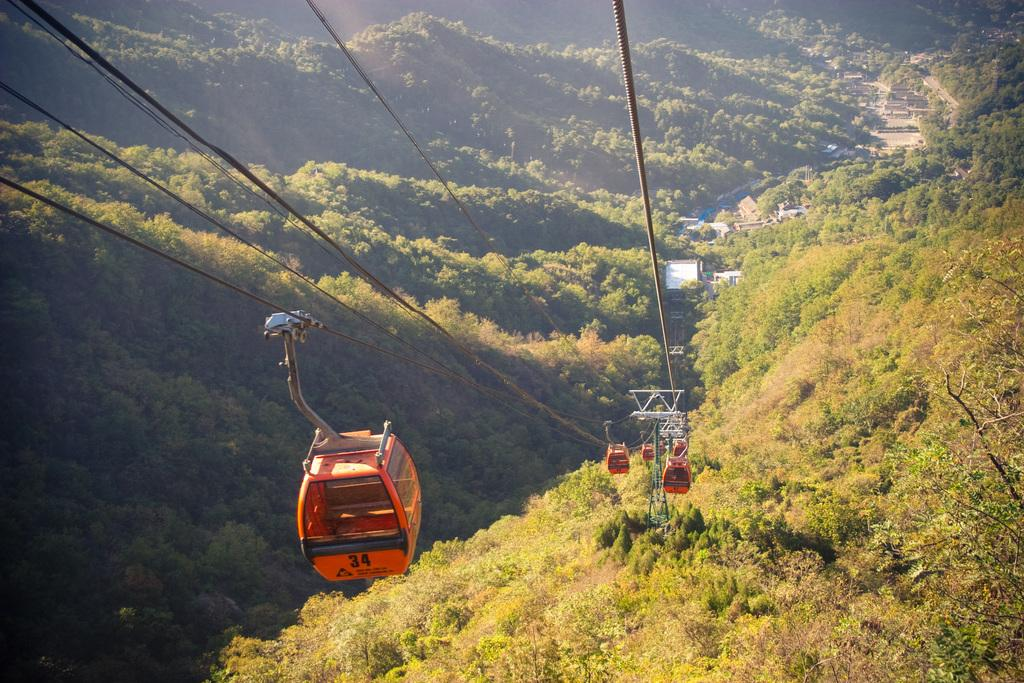What is located at the top of the image? There is a ropeway with orange boxes at the top of the image. What can be seen at the right bottom of the image? There is ground with trees at the right bottom of the image. What is visible in the background of the image? There are hills with trees in the background of the image. Where is the church located in the image? There is no church present in the image. Can you describe the toad's behavior in the image? There is no toad present in the image, so its behavior cannot be described. 